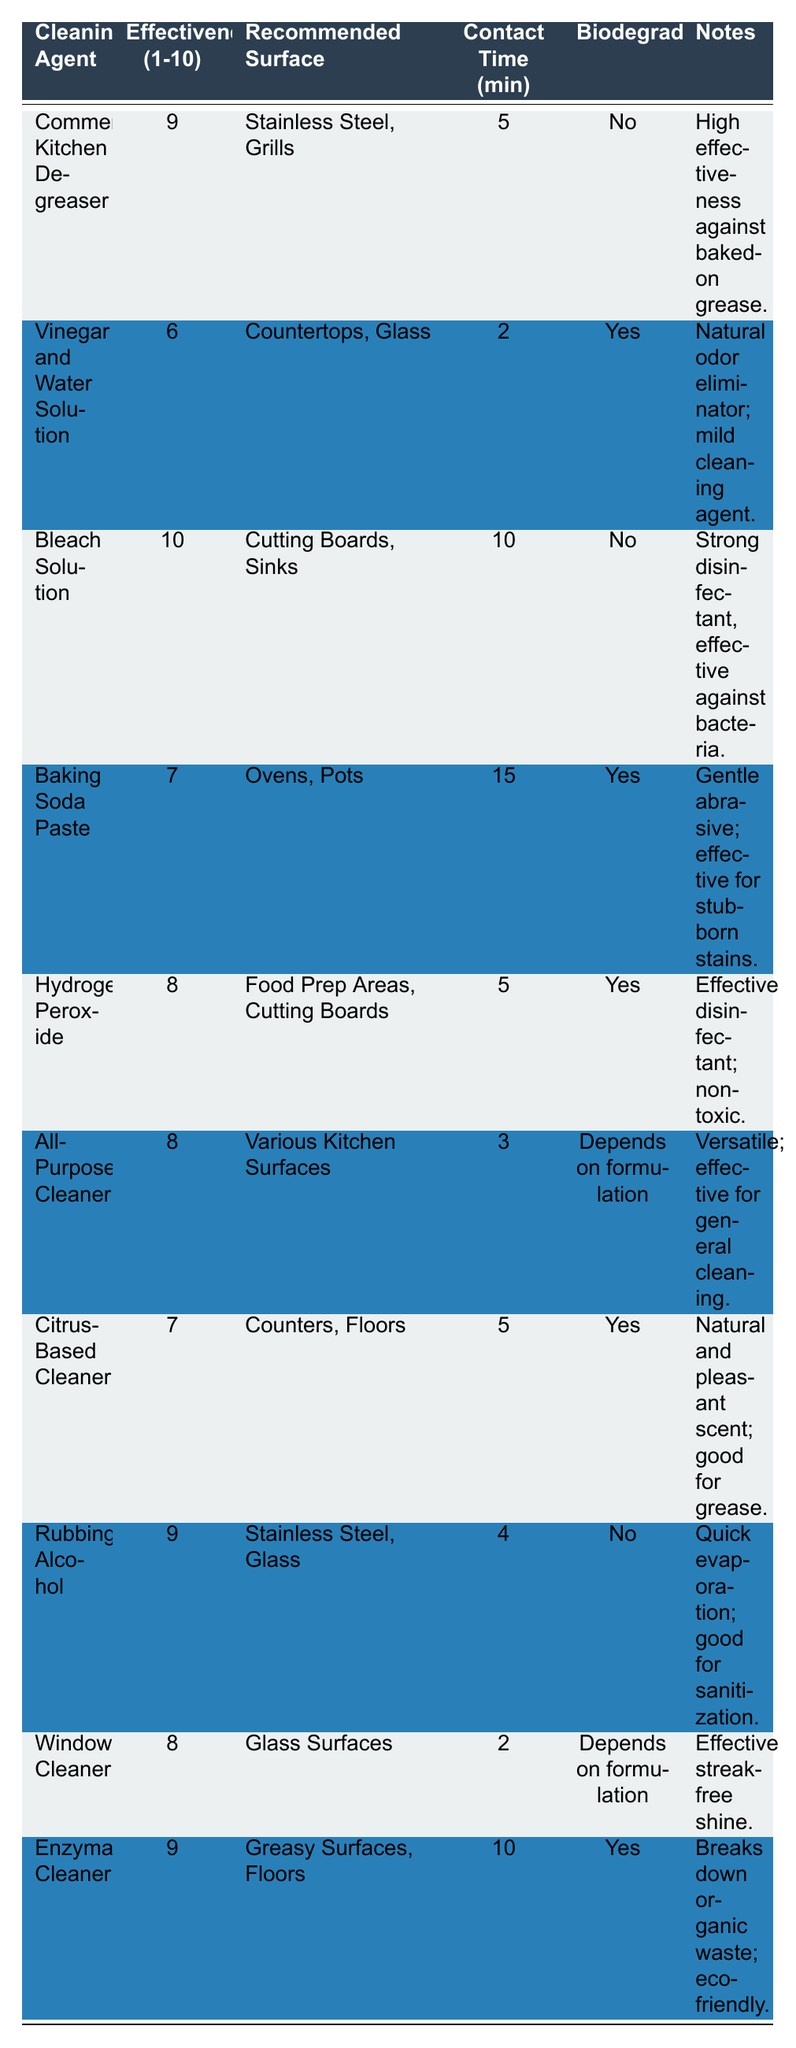What cleaning agent has the highest effectiveness rating? The table shows the effectiveness ratings for all cleaning agents. The Bleach Solution has an effectiveness rating of 10, which is the highest among all listed agents.
Answer: Bleach Solution Which cleaning agent is biodegradable? By looking at each cleaning agent's biodegradable status in the table, Vinegar and Water Solution, Baking Soda Paste, Hydrogen Peroxide, All-Purpose Cleaner (depends on formulation), Citrus-Based Cleaner, and Enzymatic Cleaner are marked as biodegradable.
Answer: Vinegar and Water Solution, Baking Soda Paste, Hydrogen Peroxide, All-Purpose Cleaner, Citrus-Based Cleaner, Enzymatic Cleaner What is the effectiveness rating of the All-Purpose Cleaner? The table lists the All-Purpose Cleaner and shows its effectiveness rating as 8, which is easily retrievable without further calculation.
Answer: 8 How many cleaning agents have an effectiveness rating of 9 or more? Counting the effectiveness ratings from the table, we see that there are four cleaning agents (Commercial Kitchen Degreaser, Bleach Solution, Rubbing Alcohol, Enzymatic Cleaner) with a rating of 9 or higher.
Answer: 4 Which cleaning agent requires the longest contact time? Comparing the contact times across all cleaning agents, Baking Soda Paste requires the longest contact time at 15 minutes. This is directly stated in the table.
Answer: Baking Soda Paste Is there a cleaning agent that is both biodegradable and has an effectiveness rating of 7? Examining the table, Vinegar and Water Solution (effectiveness 6), Baking Soda Paste (effectiveness 7), Citrus-Based Cleaner (effectiveness 7), and Enzymatic Cleaner (effectiveness 9) are biodegradable. Therefore, Baking Soda Paste and Citrus-Based Cleaner have an effectiveness rating of 7 and are biodegradable.
Answer: Yes, Baking Soda Paste and Citrus-Based Cleaner What is the average effectiveness rating of all cleaning agents listed? To find the average effectiveness, sum all ratings: 9 + 6 + 10 + 7 + 8 + 8 + 7 + 9 + 8 + 9 = 81. Then, divide by the number of agents (10) to get the average: 81 / 10 = 8.1.
Answer: 8.1 Which surface is recommended for use with Enzymatic Cleaner? The table specifies that Enzymatic Cleaner is recommended for greasy surfaces and floors. This information is found in the 'Recommended Surface' column.
Answer: Greasy Surfaces, Floors What cleaning agent has the lowest effectiveness rating? By reviewing the effectiveness ratings in the table, the Vinegar and Water Solution has the lowest rating of 6. This is a simple comparison across all entries.
Answer: Vinegar and Water Solution How does the effectiveness of Rubbing Alcohol compare to the effectiveness of Baking Soda Paste? Looking at the table, Rubbing Alcohol has an effectiveness rating of 9, while Baking Soda Paste has a rating of 7. Rubbing Alcohol is therefore more effective than Baking Soda Paste by 2 points.
Answer: Rubbing Alcohol is more effective by 2 points 